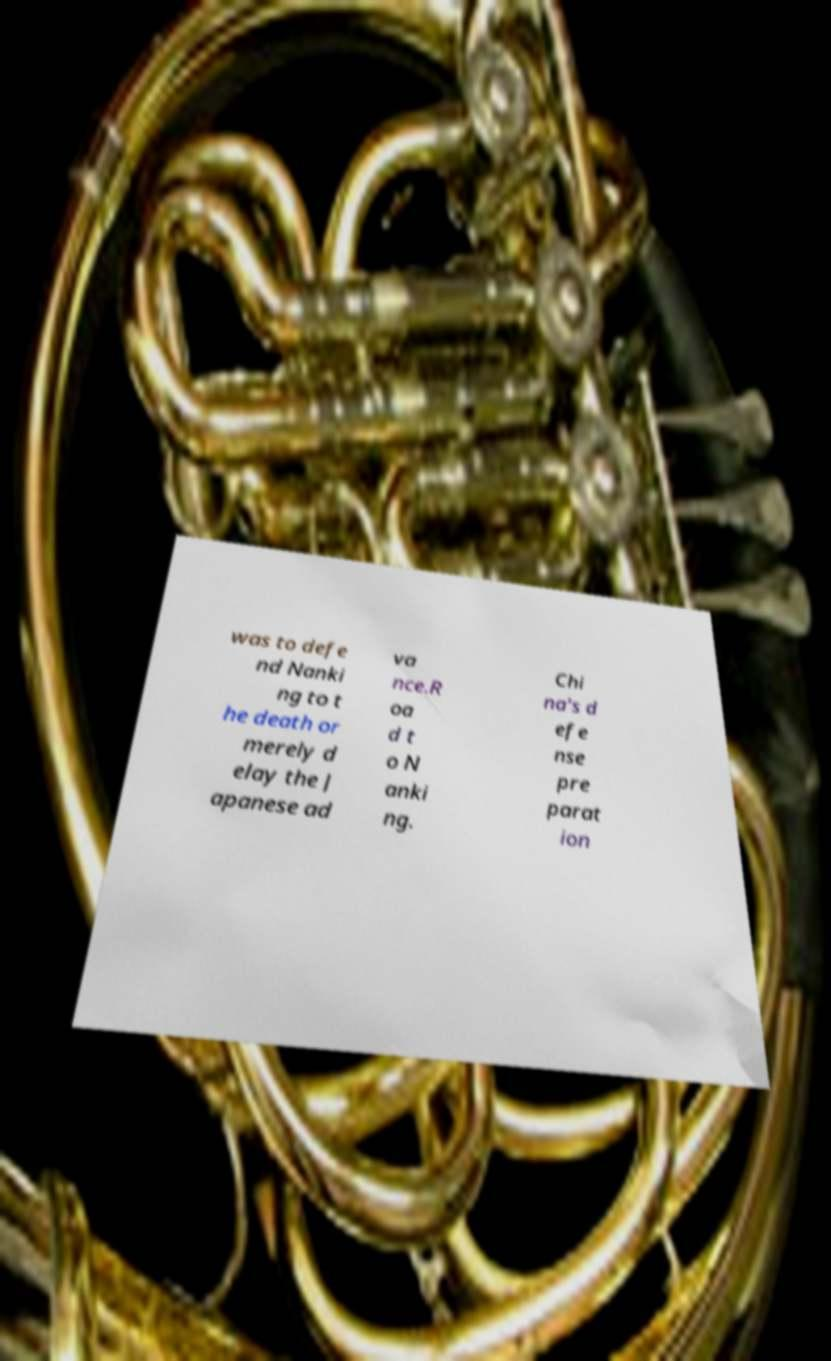What messages or text are displayed in this image? I need them in a readable, typed format. was to defe nd Nanki ng to t he death or merely d elay the J apanese ad va nce.R oa d t o N anki ng. Chi na's d efe nse pre parat ion 